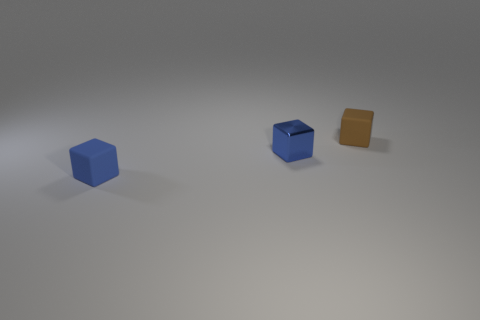Can you describe the positioning of the objects in terms of depth as seen from the perspective of this image? Certainly! From the viewpoint of the image, the objects are arranged with increasing depth. The blue cube is closest to us, followed by the metallic cube in the middle, and the brown object is furthest away. 